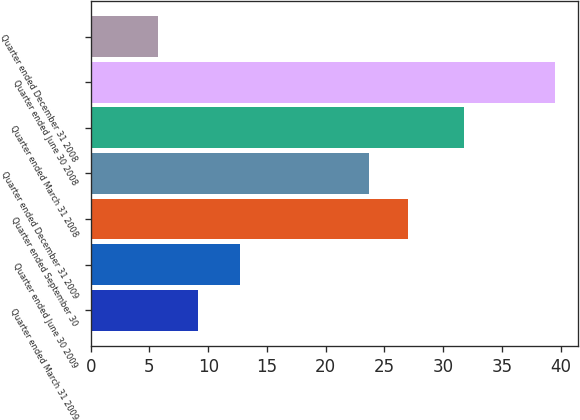Convert chart. <chart><loc_0><loc_0><loc_500><loc_500><bar_chart><fcel>Quarter ended March 31 2009<fcel>Quarter ended June 30 2009<fcel>Quarter ended September 30<fcel>Quarter ended December 31 2009<fcel>Quarter ended March 31 2008<fcel>Quarter ended June 30 2008<fcel>Quarter ended December 31 2008<nl><fcel>9.09<fcel>12.67<fcel>27.03<fcel>23.65<fcel>31.76<fcel>39.5<fcel>5.71<nl></chart> 